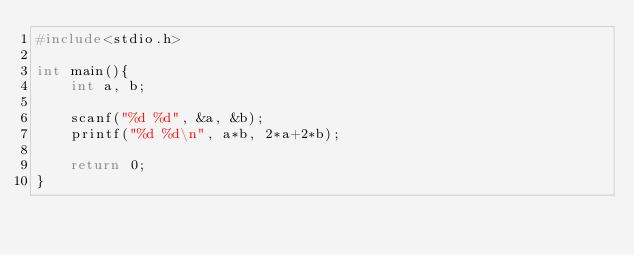Convert code to text. <code><loc_0><loc_0><loc_500><loc_500><_C_>#include<stdio.h>

int main(){
	int a, b;
	
	scanf("%d %d", &a, &b);
	printf("%d %d\n", a*b, 2*a+2*b);
	
	return 0;
}
</code> 